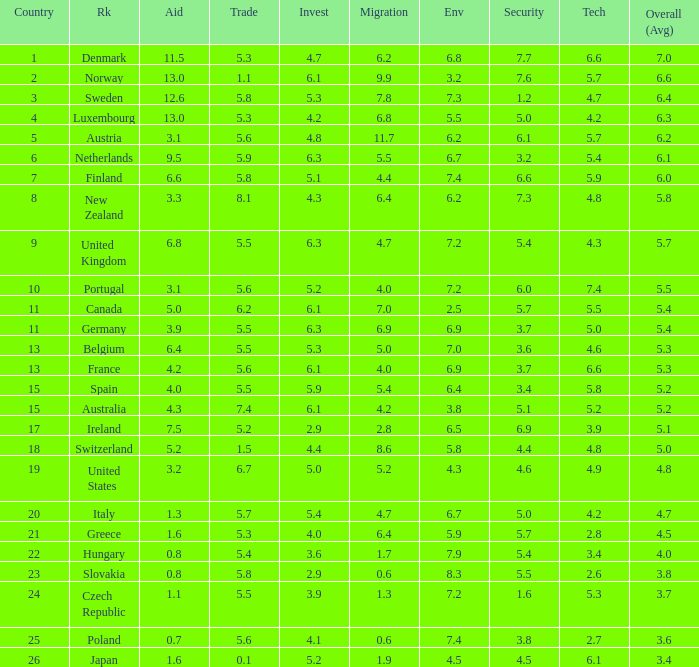What country has a 5.5 mark for security? Slovakia. 